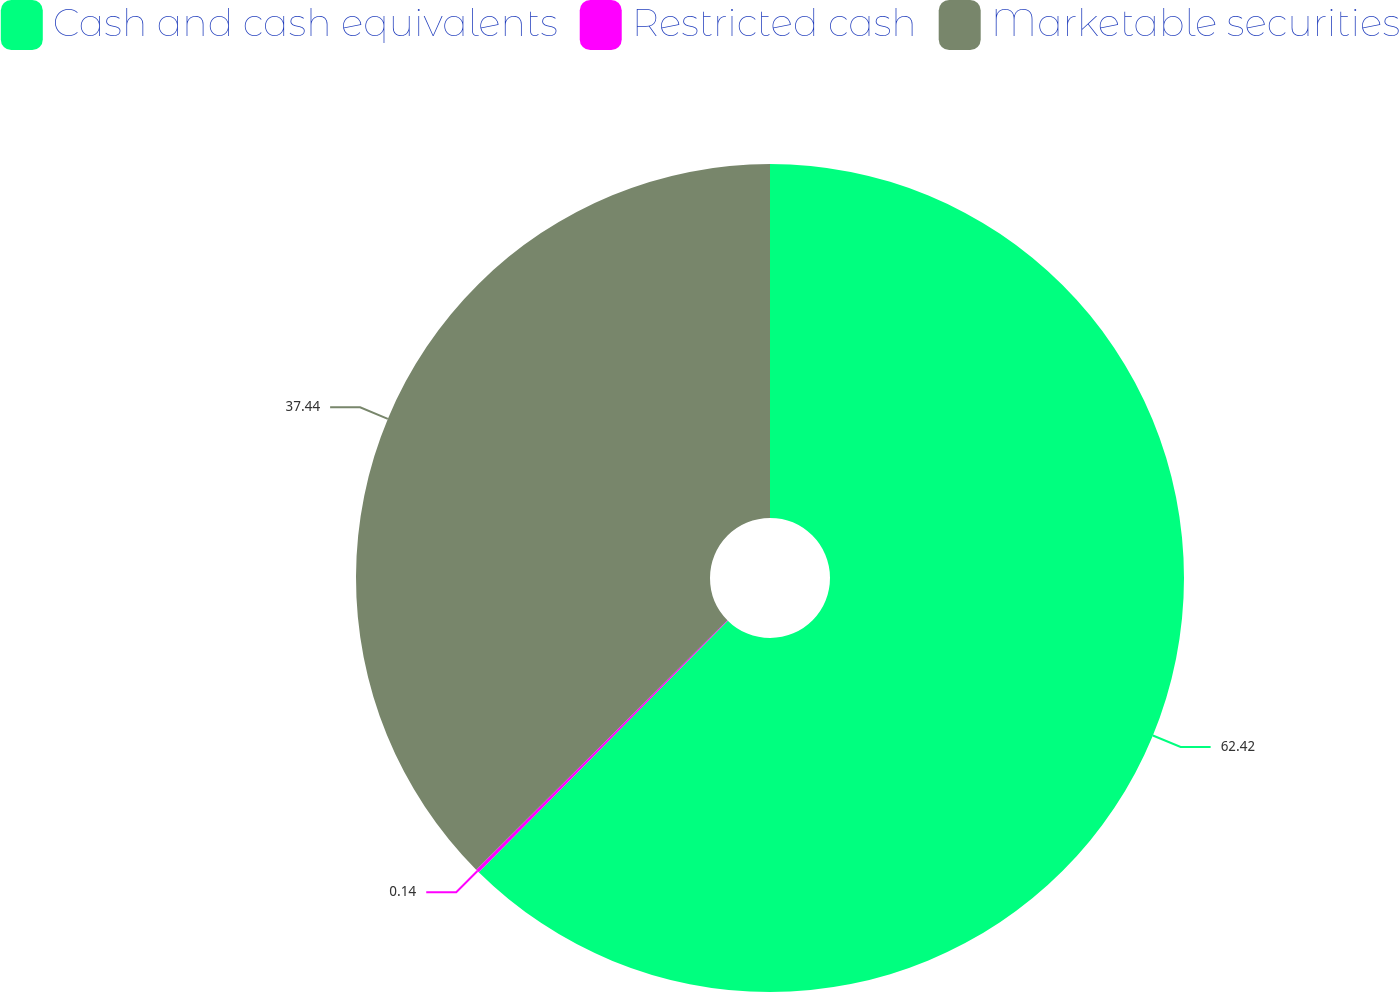<chart> <loc_0><loc_0><loc_500><loc_500><pie_chart><fcel>Cash and cash equivalents<fcel>Restricted cash<fcel>Marketable securities<nl><fcel>62.42%<fcel>0.14%<fcel>37.44%<nl></chart> 